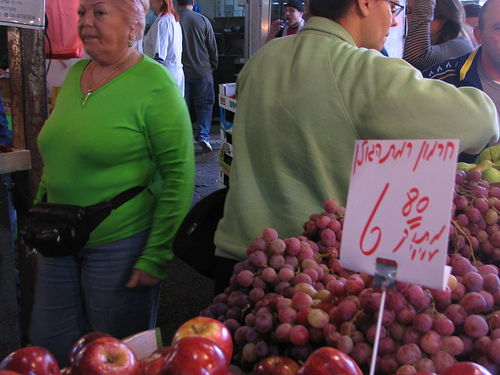Please transcribe the text in this image. 6 80 